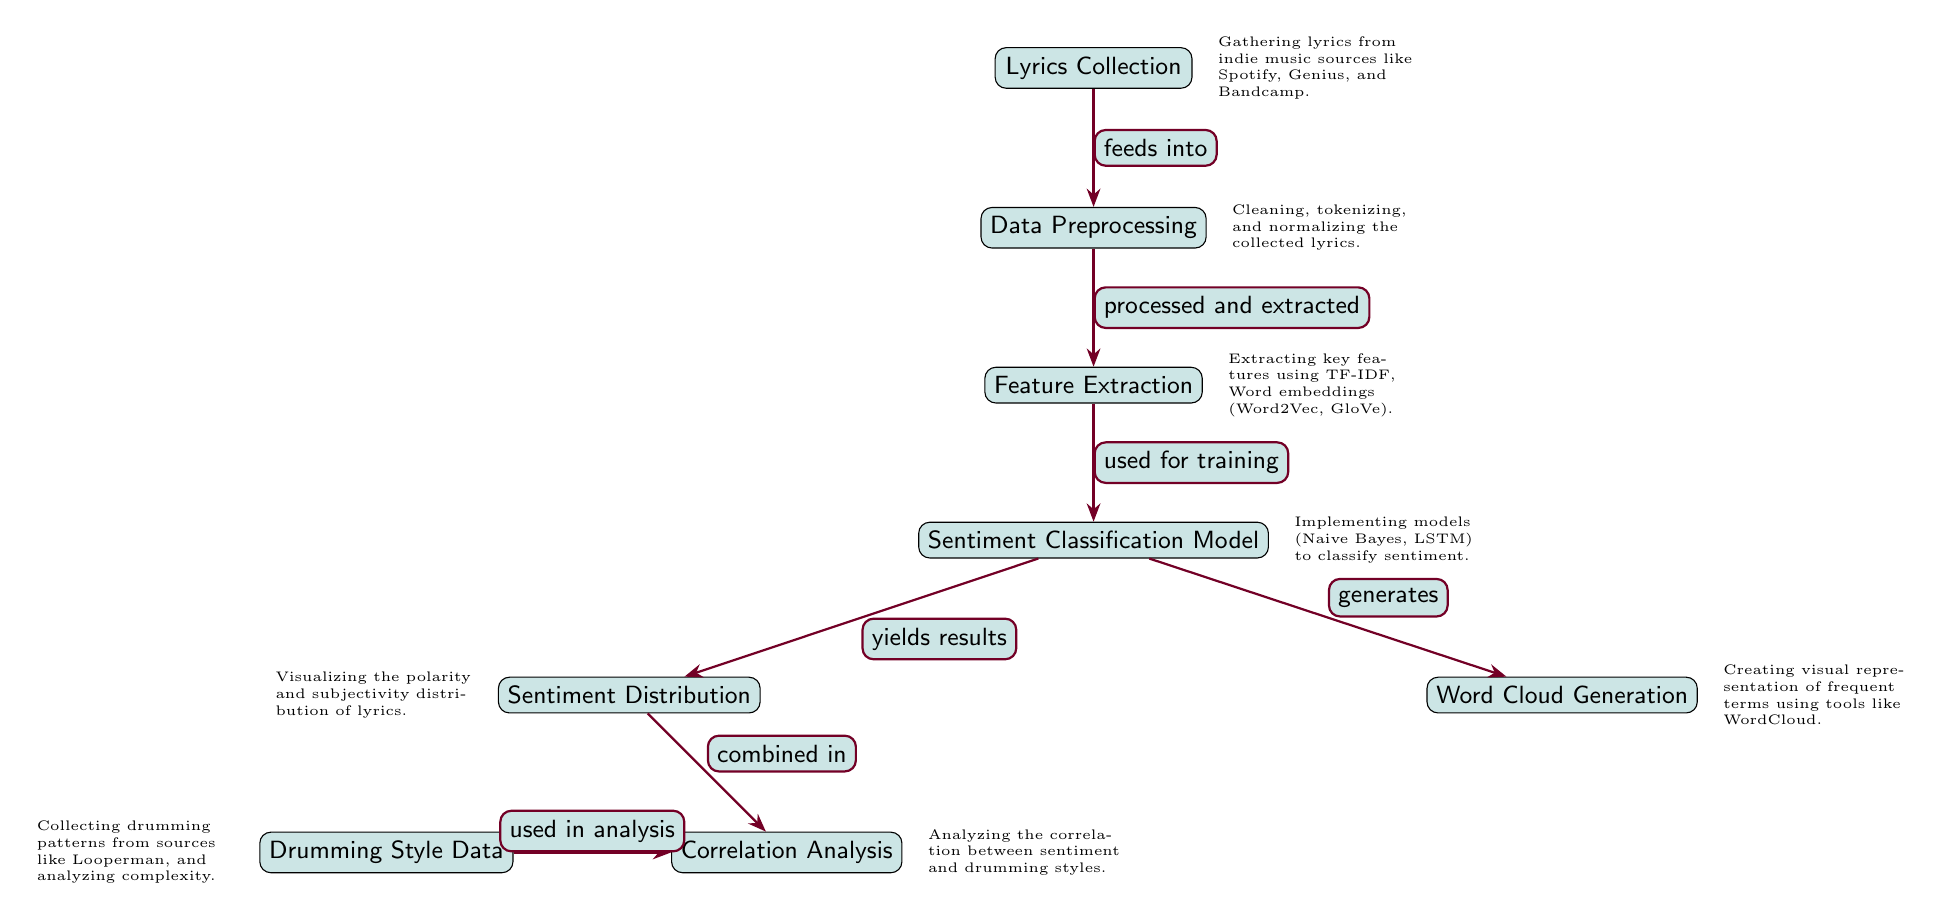What is the starting point of the process? The starting point of the diagram is the "Lyrics Collection," which is the first node that initiates the process outlined in the diagram.
Answer: Lyrics Collection How many main nodes are present in the diagram? By counting the visible nodes, there are a total of 8 main nodes, which include the activities from data collection to analysis.
Answer: 8 What is the output of the sentiment classification model? The arrow leading to "Sentiment Distribution" indicates that the output of the Sentiment Classification Model yields results that are used to visualize the sentiment distribution of the lyrics.
Answer: Sentiment Distribution Which method is used for feature extraction? The node identifies various methods, including TF-IDF and Word embeddings (Word2Vec, GloVe), as the techniques used for feature extraction during the analysis.
Answer: TF-IDF, Word embeddings How does the drumming style data relate to the overall analysis? In the diagram, the drumming style data is utilized as an input for the correlation analysis, demonstrating its role in analyzing the relationship between sentiment and drumming styles.
Answer: Used in analysis What precedes the sentiment distribution visualization? The "Sentiment Classification Model" is what processes the data and yields results that then flow into the sentiment distribution visualization as showcased in the diagram.
Answer: Sentiment Classification Model What type of visualization is created for frequent terms? The diagram specifies that a "Word Cloud Generation" node is responsible for creating visual representations of frequent terms found in the lyrics.
Answer: Word Cloud Generation Which node describes the preprocessing step for lyrics? The node labeled "Data Preprocessing" illustrates the actions taken to clean, tokenize, and normalize the collected lyrics before further analysis.
Answer: Data Preprocessing What does the correlation analysis aim to analyze? The flow indicates that the correlation analysis focuses on assessing the connection between sentiment from lyrics and drumming styles, as explicitly shown in the diagram.
Answer: Correlation between sentiment and drumming styles 